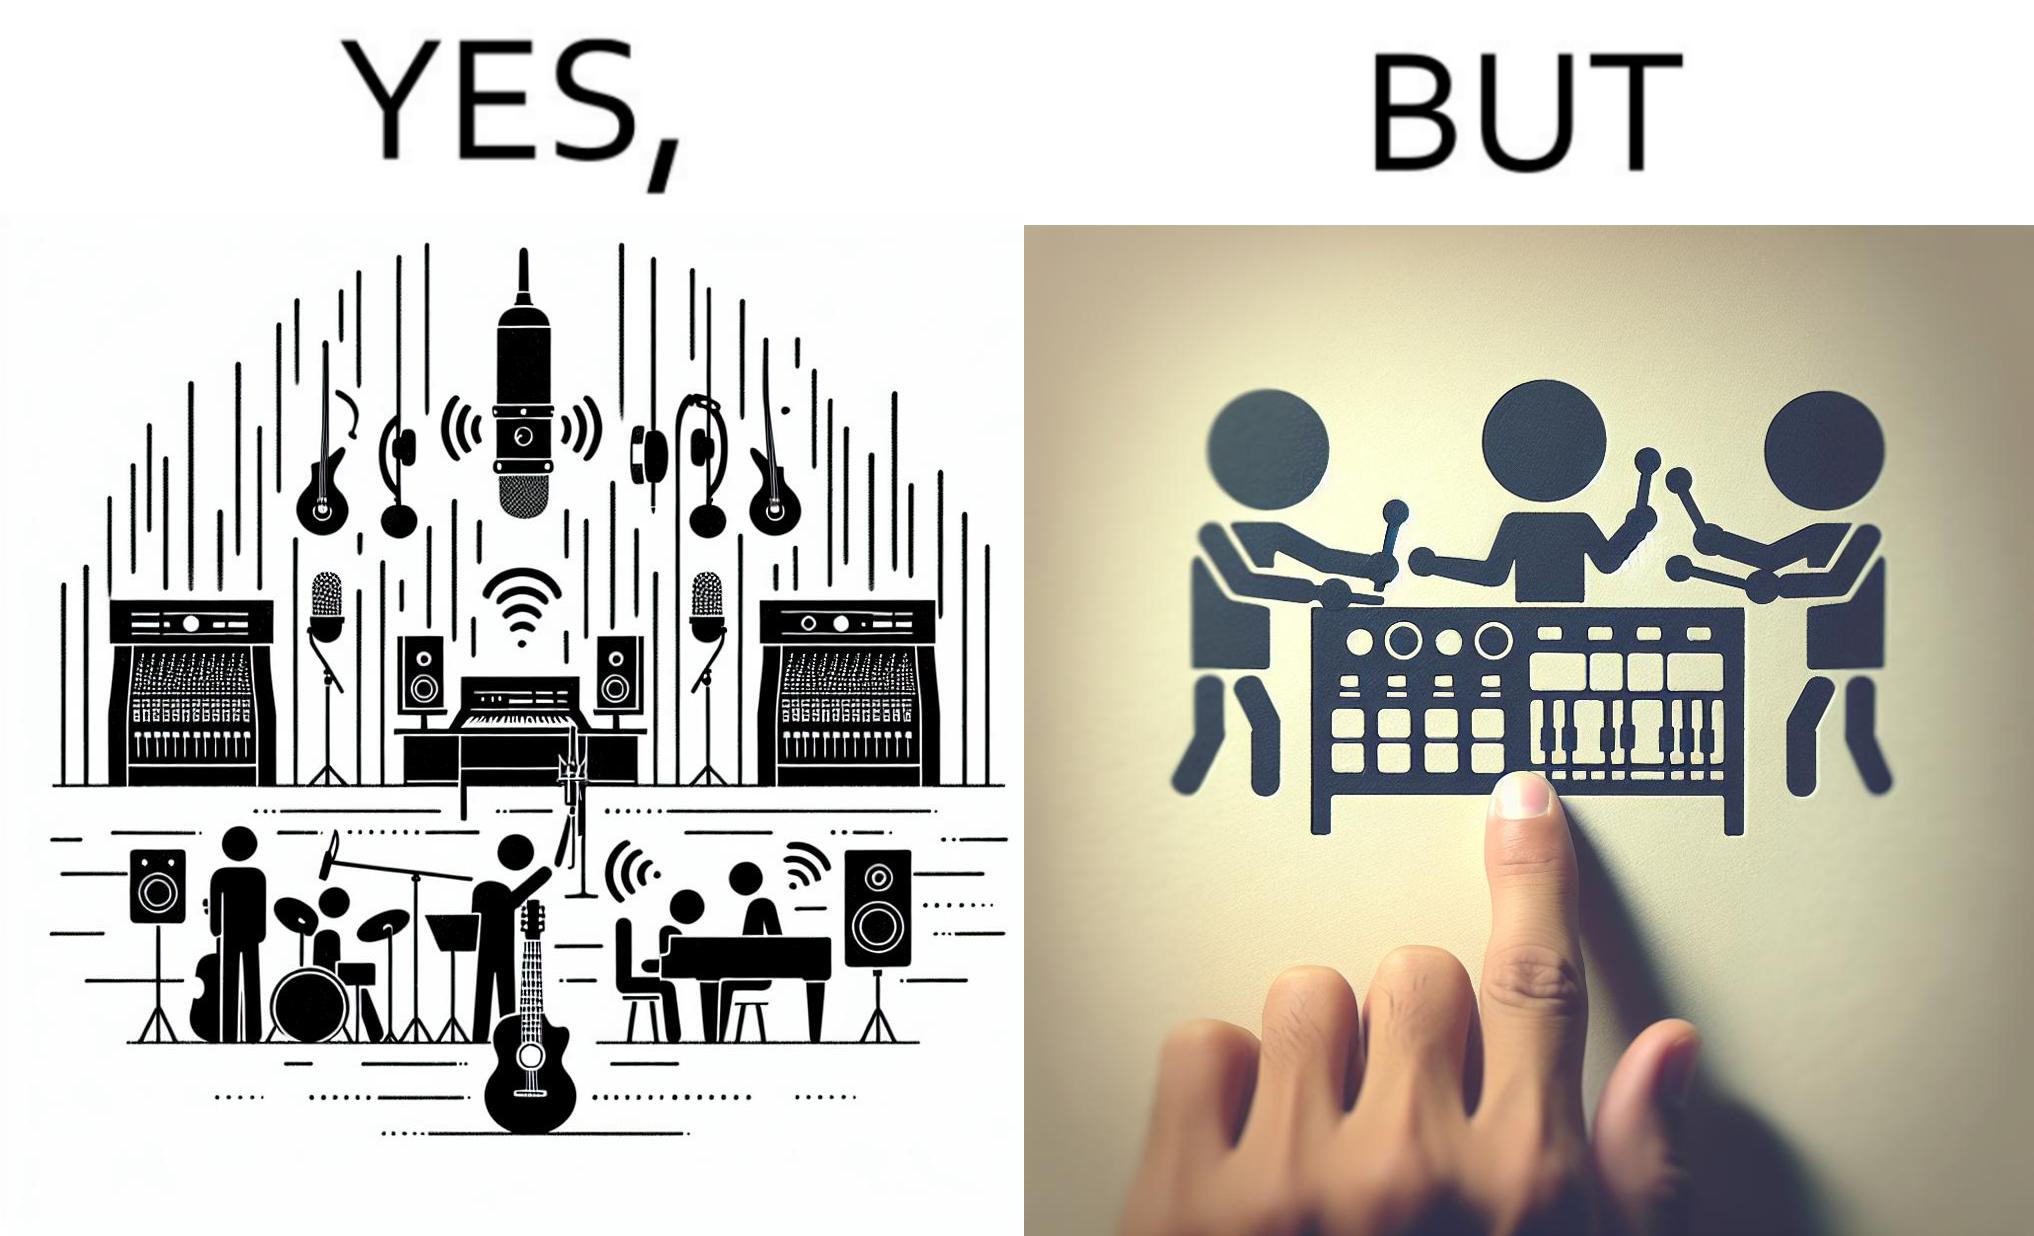What is shown in this image? The image overall is funny because even though people have great music studios and instruments to create and record music, they use electronic replacements of the musical instruments to achieve the task. 